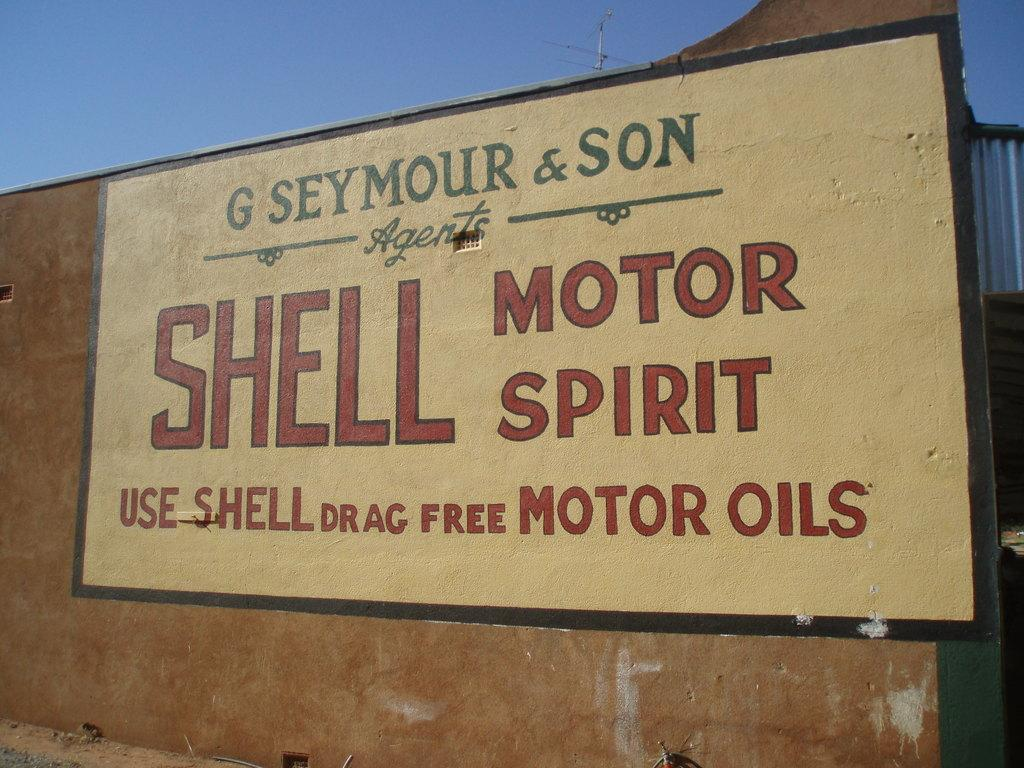Provide a one-sentence caption for the provided image. A sign advertiseing Shell drag free motor oils. 